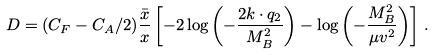<formula> <loc_0><loc_0><loc_500><loc_500>D = ( C _ { F } - C _ { A } / 2 ) \frac { \bar { x } } { x } \left [ - 2 \log \left ( - \frac { 2 k \cdot q _ { 2 } } { M _ { B } ^ { 2 } } \right ) - \log \left ( - \frac { M _ { B } ^ { 2 } } { \mu v ^ { 2 } } \right ) \right ] \, .</formula> 